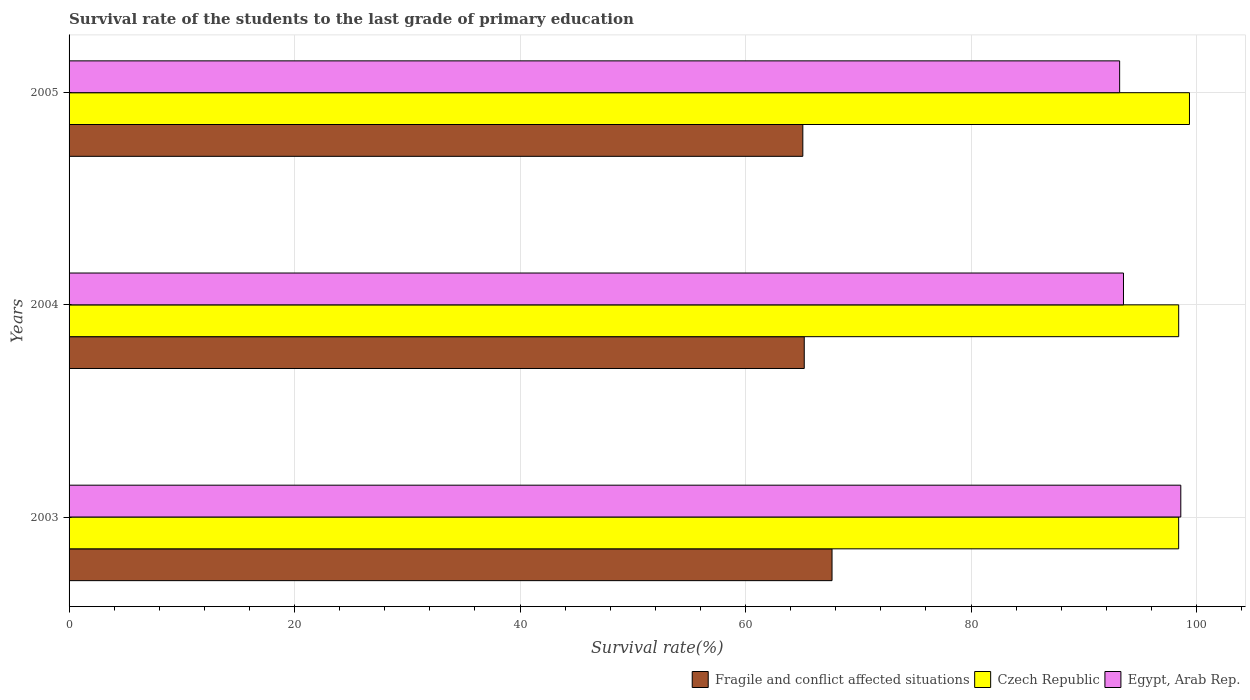How many groups of bars are there?
Your response must be concise. 3. Are the number of bars per tick equal to the number of legend labels?
Offer a very short reply. Yes. Are the number of bars on each tick of the Y-axis equal?
Make the answer very short. Yes. How many bars are there on the 3rd tick from the bottom?
Ensure brevity in your answer.  3. In how many cases, is the number of bars for a given year not equal to the number of legend labels?
Provide a short and direct response. 0. What is the survival rate of the students in Egypt, Arab Rep. in 2005?
Offer a terse response. 93.18. Across all years, what is the maximum survival rate of the students in Egypt, Arab Rep.?
Ensure brevity in your answer.  98.6. Across all years, what is the minimum survival rate of the students in Czech Republic?
Make the answer very short. 98.41. What is the total survival rate of the students in Czech Republic in the graph?
Your answer should be compact. 296.2. What is the difference between the survival rate of the students in Fragile and conflict affected situations in 2003 and that in 2004?
Provide a succinct answer. 2.46. What is the difference between the survival rate of the students in Czech Republic in 2004 and the survival rate of the students in Fragile and conflict affected situations in 2005?
Your response must be concise. 33.34. What is the average survival rate of the students in Czech Republic per year?
Keep it short and to the point. 98.73. In the year 2004, what is the difference between the survival rate of the students in Fragile and conflict affected situations and survival rate of the students in Egypt, Arab Rep.?
Ensure brevity in your answer.  -28.31. What is the ratio of the survival rate of the students in Fragile and conflict affected situations in 2003 to that in 2004?
Make the answer very short. 1.04. Is the survival rate of the students in Fragile and conflict affected situations in 2003 less than that in 2004?
Your response must be concise. No. What is the difference between the highest and the second highest survival rate of the students in Czech Republic?
Offer a terse response. 0.96. What is the difference between the highest and the lowest survival rate of the students in Fragile and conflict affected situations?
Ensure brevity in your answer.  2.59. Is the sum of the survival rate of the students in Fragile and conflict affected situations in 2003 and 2005 greater than the maximum survival rate of the students in Egypt, Arab Rep. across all years?
Your response must be concise. Yes. What does the 3rd bar from the top in 2004 represents?
Keep it short and to the point. Fragile and conflict affected situations. What does the 1st bar from the bottom in 2005 represents?
Provide a succinct answer. Fragile and conflict affected situations. What is the difference between two consecutive major ticks on the X-axis?
Provide a short and direct response. 20. Are the values on the major ticks of X-axis written in scientific E-notation?
Ensure brevity in your answer.  No. Where does the legend appear in the graph?
Provide a succinct answer. Bottom right. How are the legend labels stacked?
Offer a terse response. Horizontal. What is the title of the graph?
Your answer should be compact. Survival rate of the students to the last grade of primary education. What is the label or title of the X-axis?
Your answer should be very brief. Survival rate(%). What is the label or title of the Y-axis?
Make the answer very short. Years. What is the Survival rate(%) in Fragile and conflict affected situations in 2003?
Provide a succinct answer. 67.67. What is the Survival rate(%) of Czech Republic in 2003?
Make the answer very short. 98.41. What is the Survival rate(%) of Egypt, Arab Rep. in 2003?
Give a very brief answer. 98.6. What is the Survival rate(%) of Fragile and conflict affected situations in 2004?
Your answer should be very brief. 65.2. What is the Survival rate(%) in Czech Republic in 2004?
Ensure brevity in your answer.  98.42. What is the Survival rate(%) in Egypt, Arab Rep. in 2004?
Provide a short and direct response. 93.52. What is the Survival rate(%) of Fragile and conflict affected situations in 2005?
Your answer should be very brief. 65.08. What is the Survival rate(%) in Czech Republic in 2005?
Your answer should be very brief. 99.37. What is the Survival rate(%) in Egypt, Arab Rep. in 2005?
Your answer should be compact. 93.18. Across all years, what is the maximum Survival rate(%) in Fragile and conflict affected situations?
Offer a very short reply. 67.67. Across all years, what is the maximum Survival rate(%) of Czech Republic?
Provide a succinct answer. 99.37. Across all years, what is the maximum Survival rate(%) in Egypt, Arab Rep.?
Offer a very short reply. 98.6. Across all years, what is the minimum Survival rate(%) of Fragile and conflict affected situations?
Your response must be concise. 65.08. Across all years, what is the minimum Survival rate(%) in Czech Republic?
Offer a terse response. 98.41. Across all years, what is the minimum Survival rate(%) of Egypt, Arab Rep.?
Give a very brief answer. 93.18. What is the total Survival rate(%) in Fragile and conflict affected situations in the graph?
Make the answer very short. 197.95. What is the total Survival rate(%) of Czech Republic in the graph?
Make the answer very short. 296.2. What is the total Survival rate(%) in Egypt, Arab Rep. in the graph?
Keep it short and to the point. 285.3. What is the difference between the Survival rate(%) of Fragile and conflict affected situations in 2003 and that in 2004?
Your answer should be compact. 2.46. What is the difference between the Survival rate(%) of Czech Republic in 2003 and that in 2004?
Keep it short and to the point. -0. What is the difference between the Survival rate(%) in Egypt, Arab Rep. in 2003 and that in 2004?
Provide a succinct answer. 5.08. What is the difference between the Survival rate(%) in Fragile and conflict affected situations in 2003 and that in 2005?
Your response must be concise. 2.59. What is the difference between the Survival rate(%) in Czech Republic in 2003 and that in 2005?
Your answer should be compact. -0.96. What is the difference between the Survival rate(%) of Egypt, Arab Rep. in 2003 and that in 2005?
Keep it short and to the point. 5.42. What is the difference between the Survival rate(%) of Fragile and conflict affected situations in 2004 and that in 2005?
Give a very brief answer. 0.13. What is the difference between the Survival rate(%) in Czech Republic in 2004 and that in 2005?
Offer a very short reply. -0.96. What is the difference between the Survival rate(%) in Egypt, Arab Rep. in 2004 and that in 2005?
Your response must be concise. 0.34. What is the difference between the Survival rate(%) of Fragile and conflict affected situations in 2003 and the Survival rate(%) of Czech Republic in 2004?
Your answer should be compact. -30.75. What is the difference between the Survival rate(%) of Fragile and conflict affected situations in 2003 and the Survival rate(%) of Egypt, Arab Rep. in 2004?
Give a very brief answer. -25.85. What is the difference between the Survival rate(%) of Czech Republic in 2003 and the Survival rate(%) of Egypt, Arab Rep. in 2004?
Your answer should be compact. 4.89. What is the difference between the Survival rate(%) in Fragile and conflict affected situations in 2003 and the Survival rate(%) in Czech Republic in 2005?
Make the answer very short. -31.7. What is the difference between the Survival rate(%) of Fragile and conflict affected situations in 2003 and the Survival rate(%) of Egypt, Arab Rep. in 2005?
Make the answer very short. -25.51. What is the difference between the Survival rate(%) of Czech Republic in 2003 and the Survival rate(%) of Egypt, Arab Rep. in 2005?
Provide a succinct answer. 5.23. What is the difference between the Survival rate(%) of Fragile and conflict affected situations in 2004 and the Survival rate(%) of Czech Republic in 2005?
Give a very brief answer. -34.17. What is the difference between the Survival rate(%) of Fragile and conflict affected situations in 2004 and the Survival rate(%) of Egypt, Arab Rep. in 2005?
Your response must be concise. -27.97. What is the difference between the Survival rate(%) of Czech Republic in 2004 and the Survival rate(%) of Egypt, Arab Rep. in 2005?
Provide a succinct answer. 5.24. What is the average Survival rate(%) of Fragile and conflict affected situations per year?
Your response must be concise. 65.98. What is the average Survival rate(%) in Czech Republic per year?
Your response must be concise. 98.73. What is the average Survival rate(%) of Egypt, Arab Rep. per year?
Offer a very short reply. 95.1. In the year 2003, what is the difference between the Survival rate(%) of Fragile and conflict affected situations and Survival rate(%) of Czech Republic?
Offer a very short reply. -30.74. In the year 2003, what is the difference between the Survival rate(%) in Fragile and conflict affected situations and Survival rate(%) in Egypt, Arab Rep.?
Ensure brevity in your answer.  -30.93. In the year 2003, what is the difference between the Survival rate(%) of Czech Republic and Survival rate(%) of Egypt, Arab Rep.?
Offer a very short reply. -0.19. In the year 2004, what is the difference between the Survival rate(%) of Fragile and conflict affected situations and Survival rate(%) of Czech Republic?
Provide a short and direct response. -33.21. In the year 2004, what is the difference between the Survival rate(%) in Fragile and conflict affected situations and Survival rate(%) in Egypt, Arab Rep.?
Keep it short and to the point. -28.31. In the year 2004, what is the difference between the Survival rate(%) in Czech Republic and Survival rate(%) in Egypt, Arab Rep.?
Your response must be concise. 4.9. In the year 2005, what is the difference between the Survival rate(%) of Fragile and conflict affected situations and Survival rate(%) of Czech Republic?
Provide a short and direct response. -34.29. In the year 2005, what is the difference between the Survival rate(%) in Fragile and conflict affected situations and Survival rate(%) in Egypt, Arab Rep.?
Ensure brevity in your answer.  -28.1. In the year 2005, what is the difference between the Survival rate(%) of Czech Republic and Survival rate(%) of Egypt, Arab Rep.?
Offer a terse response. 6.19. What is the ratio of the Survival rate(%) of Fragile and conflict affected situations in 2003 to that in 2004?
Provide a short and direct response. 1.04. What is the ratio of the Survival rate(%) in Egypt, Arab Rep. in 2003 to that in 2004?
Keep it short and to the point. 1.05. What is the ratio of the Survival rate(%) of Fragile and conflict affected situations in 2003 to that in 2005?
Give a very brief answer. 1.04. What is the ratio of the Survival rate(%) of Czech Republic in 2003 to that in 2005?
Keep it short and to the point. 0.99. What is the ratio of the Survival rate(%) of Egypt, Arab Rep. in 2003 to that in 2005?
Make the answer very short. 1.06. What is the ratio of the Survival rate(%) in Czech Republic in 2004 to that in 2005?
Provide a short and direct response. 0.99. What is the ratio of the Survival rate(%) of Egypt, Arab Rep. in 2004 to that in 2005?
Ensure brevity in your answer.  1. What is the difference between the highest and the second highest Survival rate(%) of Fragile and conflict affected situations?
Offer a very short reply. 2.46. What is the difference between the highest and the second highest Survival rate(%) of Czech Republic?
Offer a very short reply. 0.96. What is the difference between the highest and the second highest Survival rate(%) of Egypt, Arab Rep.?
Ensure brevity in your answer.  5.08. What is the difference between the highest and the lowest Survival rate(%) in Fragile and conflict affected situations?
Provide a succinct answer. 2.59. What is the difference between the highest and the lowest Survival rate(%) in Czech Republic?
Provide a succinct answer. 0.96. What is the difference between the highest and the lowest Survival rate(%) of Egypt, Arab Rep.?
Ensure brevity in your answer.  5.42. 